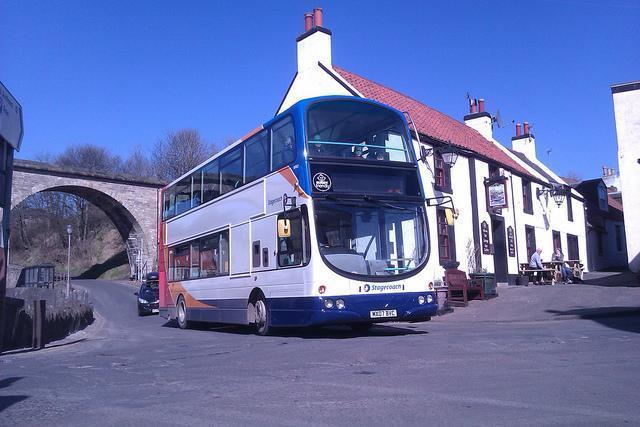How many chimneys are on the roof?
Give a very brief answer. 3. How many birds are in the water?
Give a very brief answer. 0. 